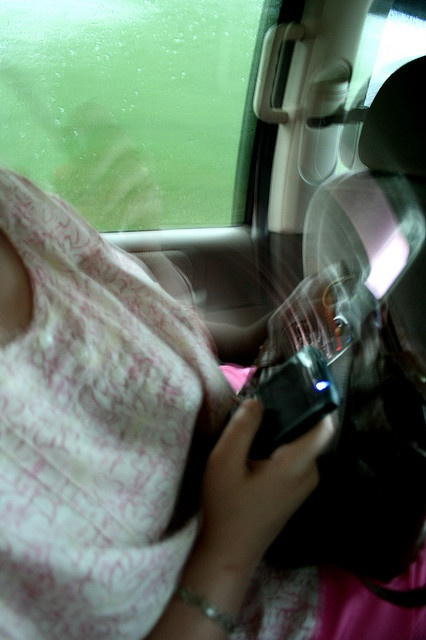Describe the objects in this image and their specific colors. I can see people in lightblue, darkgray, gray, and black tones and cell phone in lightblue, black, teal, and gray tones in this image. 